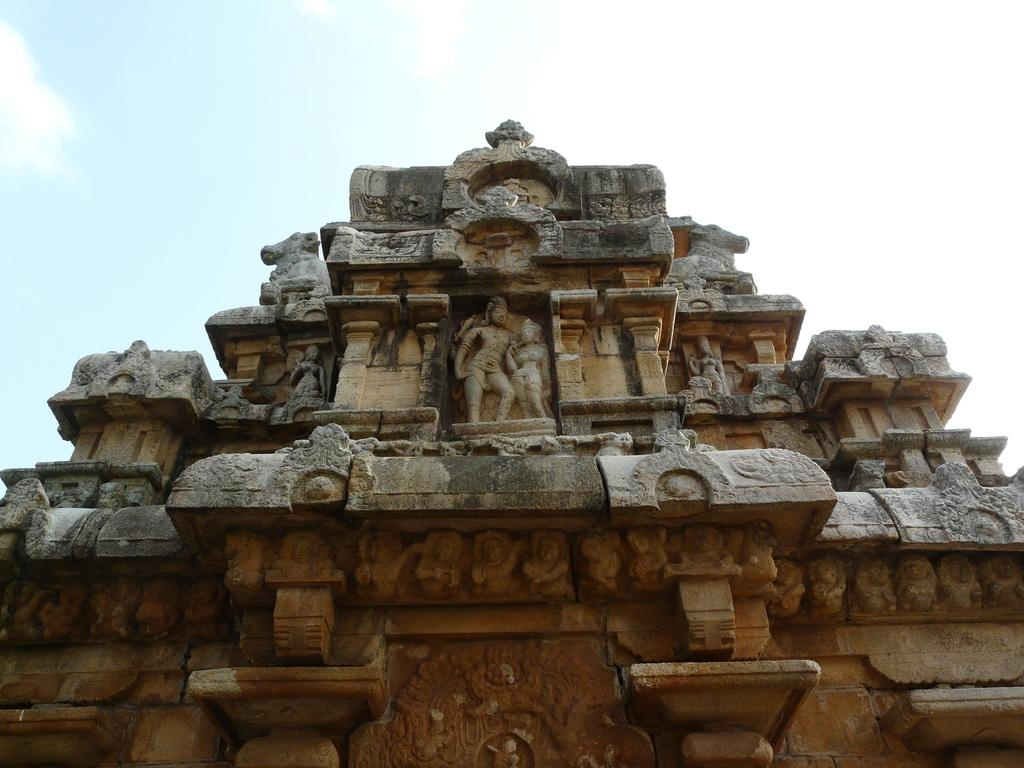What is the main subject of the image? There is a monument in the image. What else can be seen in the image besides the monument? The sky is visible in the image. How would you describe the sky in the image? The sky appears to be cloudy. How many noses can be seen on the monument in the image? There are no noses present on the monument in the image. What type of fowl is perched on the monument in the image? There are no fowl present on the monument in the image. 